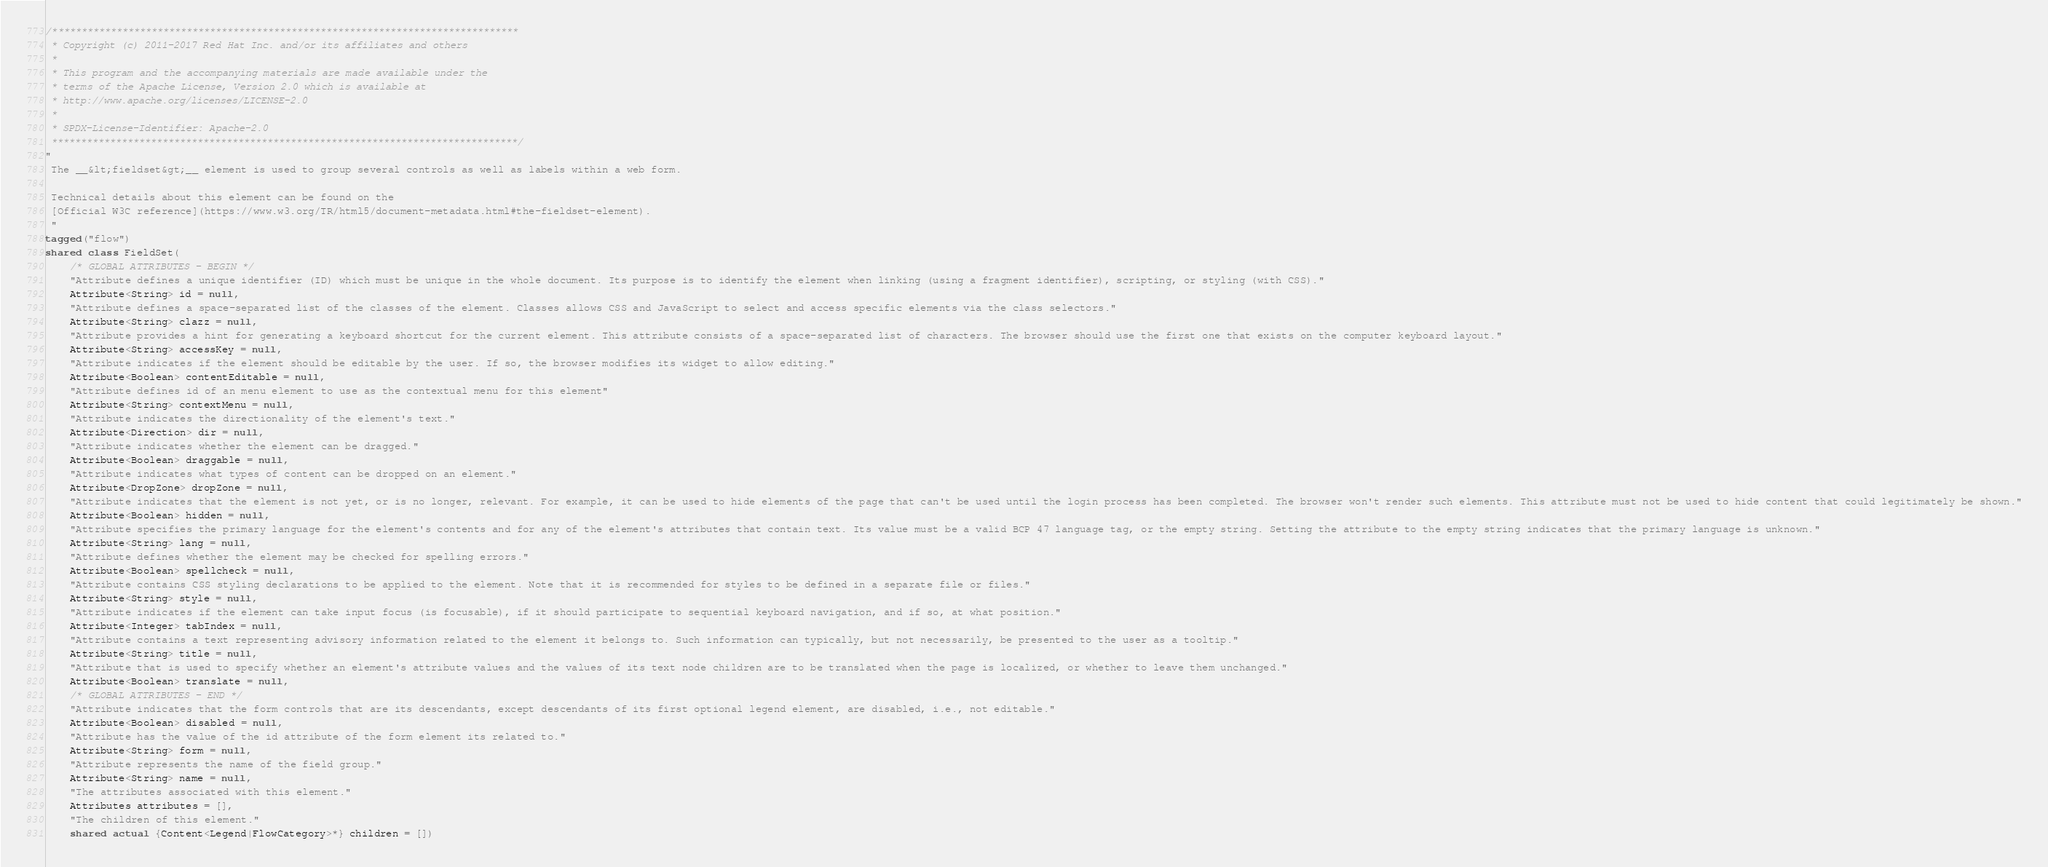<code> <loc_0><loc_0><loc_500><loc_500><_Ceylon_>/********************************************************************************
 * Copyright (c) 2011-2017 Red Hat Inc. and/or its affiliates and others
 *
 * This program and the accompanying materials are made available under the 
 * terms of the Apache License, Version 2.0 which is available at
 * http://www.apache.org/licenses/LICENSE-2.0
 *
 * SPDX-License-Identifier: Apache-2.0 
 ********************************************************************************/
"
 The __&lt;fieldset&gt;__ element is used to group several controls as well as labels within a web form.
 
 Technical details about this element can be found on the
 [Official W3C reference](https://www.w3.org/TR/html5/document-metadata.html#the-fieldset-element).
 "
tagged("flow")
shared class FieldSet(
    /* GLOBAL ATTRIBUTES - BEGIN */
    "Attribute defines a unique identifier (ID) which must be unique in the whole document. Its purpose is to identify the element when linking (using a fragment identifier), scripting, or styling (with CSS)."
    Attribute<String> id = null,
    "Attribute defines a space-separated list of the classes of the element. Classes allows CSS and JavaScript to select and access specific elements via the class selectors."
    Attribute<String> clazz = null,
    "Attribute provides a hint for generating a keyboard shortcut for the current element. This attribute consists of a space-separated list of characters. The browser should use the first one that exists on the computer keyboard layout."
    Attribute<String> accessKey = null,
    "Attribute indicates if the element should be editable by the user. If so, the browser modifies its widget to allow editing."
    Attribute<Boolean> contentEditable = null,
    "Attribute defines id of an menu element to use as the contextual menu for this element"
    Attribute<String> contextMenu = null,
    "Attribute indicates the directionality of the element's text."
    Attribute<Direction> dir = null,
    "Attribute indicates whether the element can be dragged."
    Attribute<Boolean> draggable = null,
    "Attribute indicates what types of content can be dropped on an element."
    Attribute<DropZone> dropZone = null,
    "Attribute indicates that the element is not yet, or is no longer, relevant. For example, it can be used to hide elements of the page that can't be used until the login process has been completed. The browser won't render such elements. This attribute must not be used to hide content that could legitimately be shown."
    Attribute<Boolean> hidden = null,
    "Attribute specifies the primary language for the element's contents and for any of the element's attributes that contain text. Its value must be a valid BCP 47 language tag, or the empty string. Setting the attribute to the empty string indicates that the primary language is unknown."
    Attribute<String> lang = null,
    "Attribute defines whether the element may be checked for spelling errors."
    Attribute<Boolean> spellcheck = null,
    "Attribute contains CSS styling declarations to be applied to the element. Note that it is recommended for styles to be defined in a separate file or files."
    Attribute<String> style = null,
    "Attribute indicates if the element can take input focus (is focusable), if it should participate to sequential keyboard navigation, and if so, at what position."
    Attribute<Integer> tabIndex = null,
    "Attribute contains a text representing advisory information related to the element it belongs to. Such information can typically, but not necessarily, be presented to the user as a tooltip."
    Attribute<String> title = null,
    "Attribute that is used to specify whether an element's attribute values and the values of its text node children are to be translated when the page is localized, or whether to leave them unchanged."
    Attribute<Boolean> translate = null,
    /* GLOBAL ATTRIBUTES - END */
    "Attribute indicates that the form controls that are its descendants, except descendants of its first optional legend element, are disabled, i.e., not editable."
    Attribute<Boolean> disabled = null,
    "Attribute has the value of the id attribute of the form element its related to."
    Attribute<String> form = null,
    "Attribute represents the name of the field group."
    Attribute<String> name = null,
    "The attributes associated with this element."
    Attributes attributes = [],
    "The children of this element."
    shared actual {Content<Legend|FlowCategory>*} children = [])</code> 